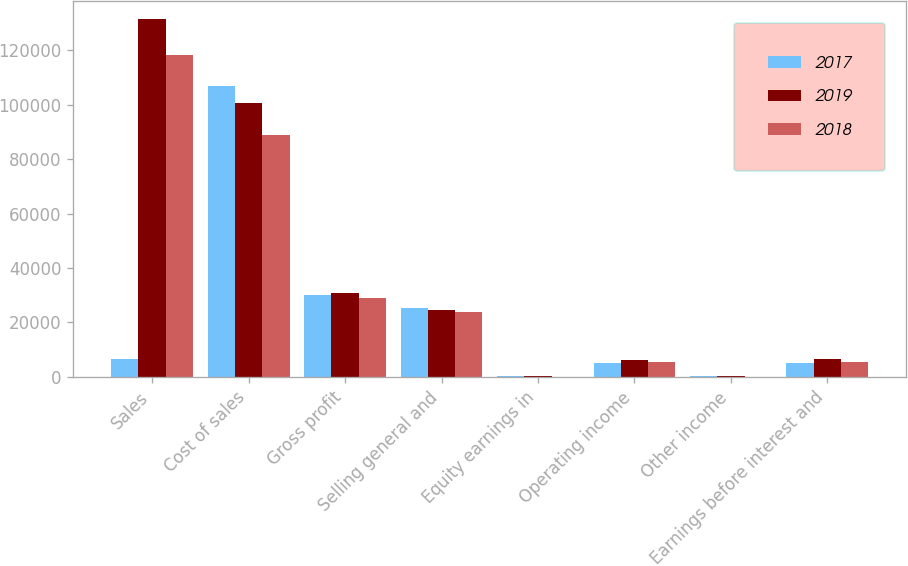Convert chart. <chart><loc_0><loc_0><loc_500><loc_500><stacked_bar_chart><ecel><fcel>Sales<fcel>Cost of sales<fcel>Gross profit<fcel>Selling general and<fcel>Equity earnings in<fcel>Operating income<fcel>Other income<fcel>Earnings before interest and<nl><fcel>2017<fcel>6591<fcel>106790<fcel>30076<fcel>25242<fcel>164<fcel>4998<fcel>233<fcel>5231<nl><fcel>2019<fcel>131537<fcel>100745<fcel>30792<fcel>24694<fcel>191<fcel>6289<fcel>302<fcel>6591<nl><fcel>2018<fcel>118214<fcel>89052<fcel>29162<fcel>23813<fcel>135<fcel>5484<fcel>62<fcel>5546<nl></chart> 